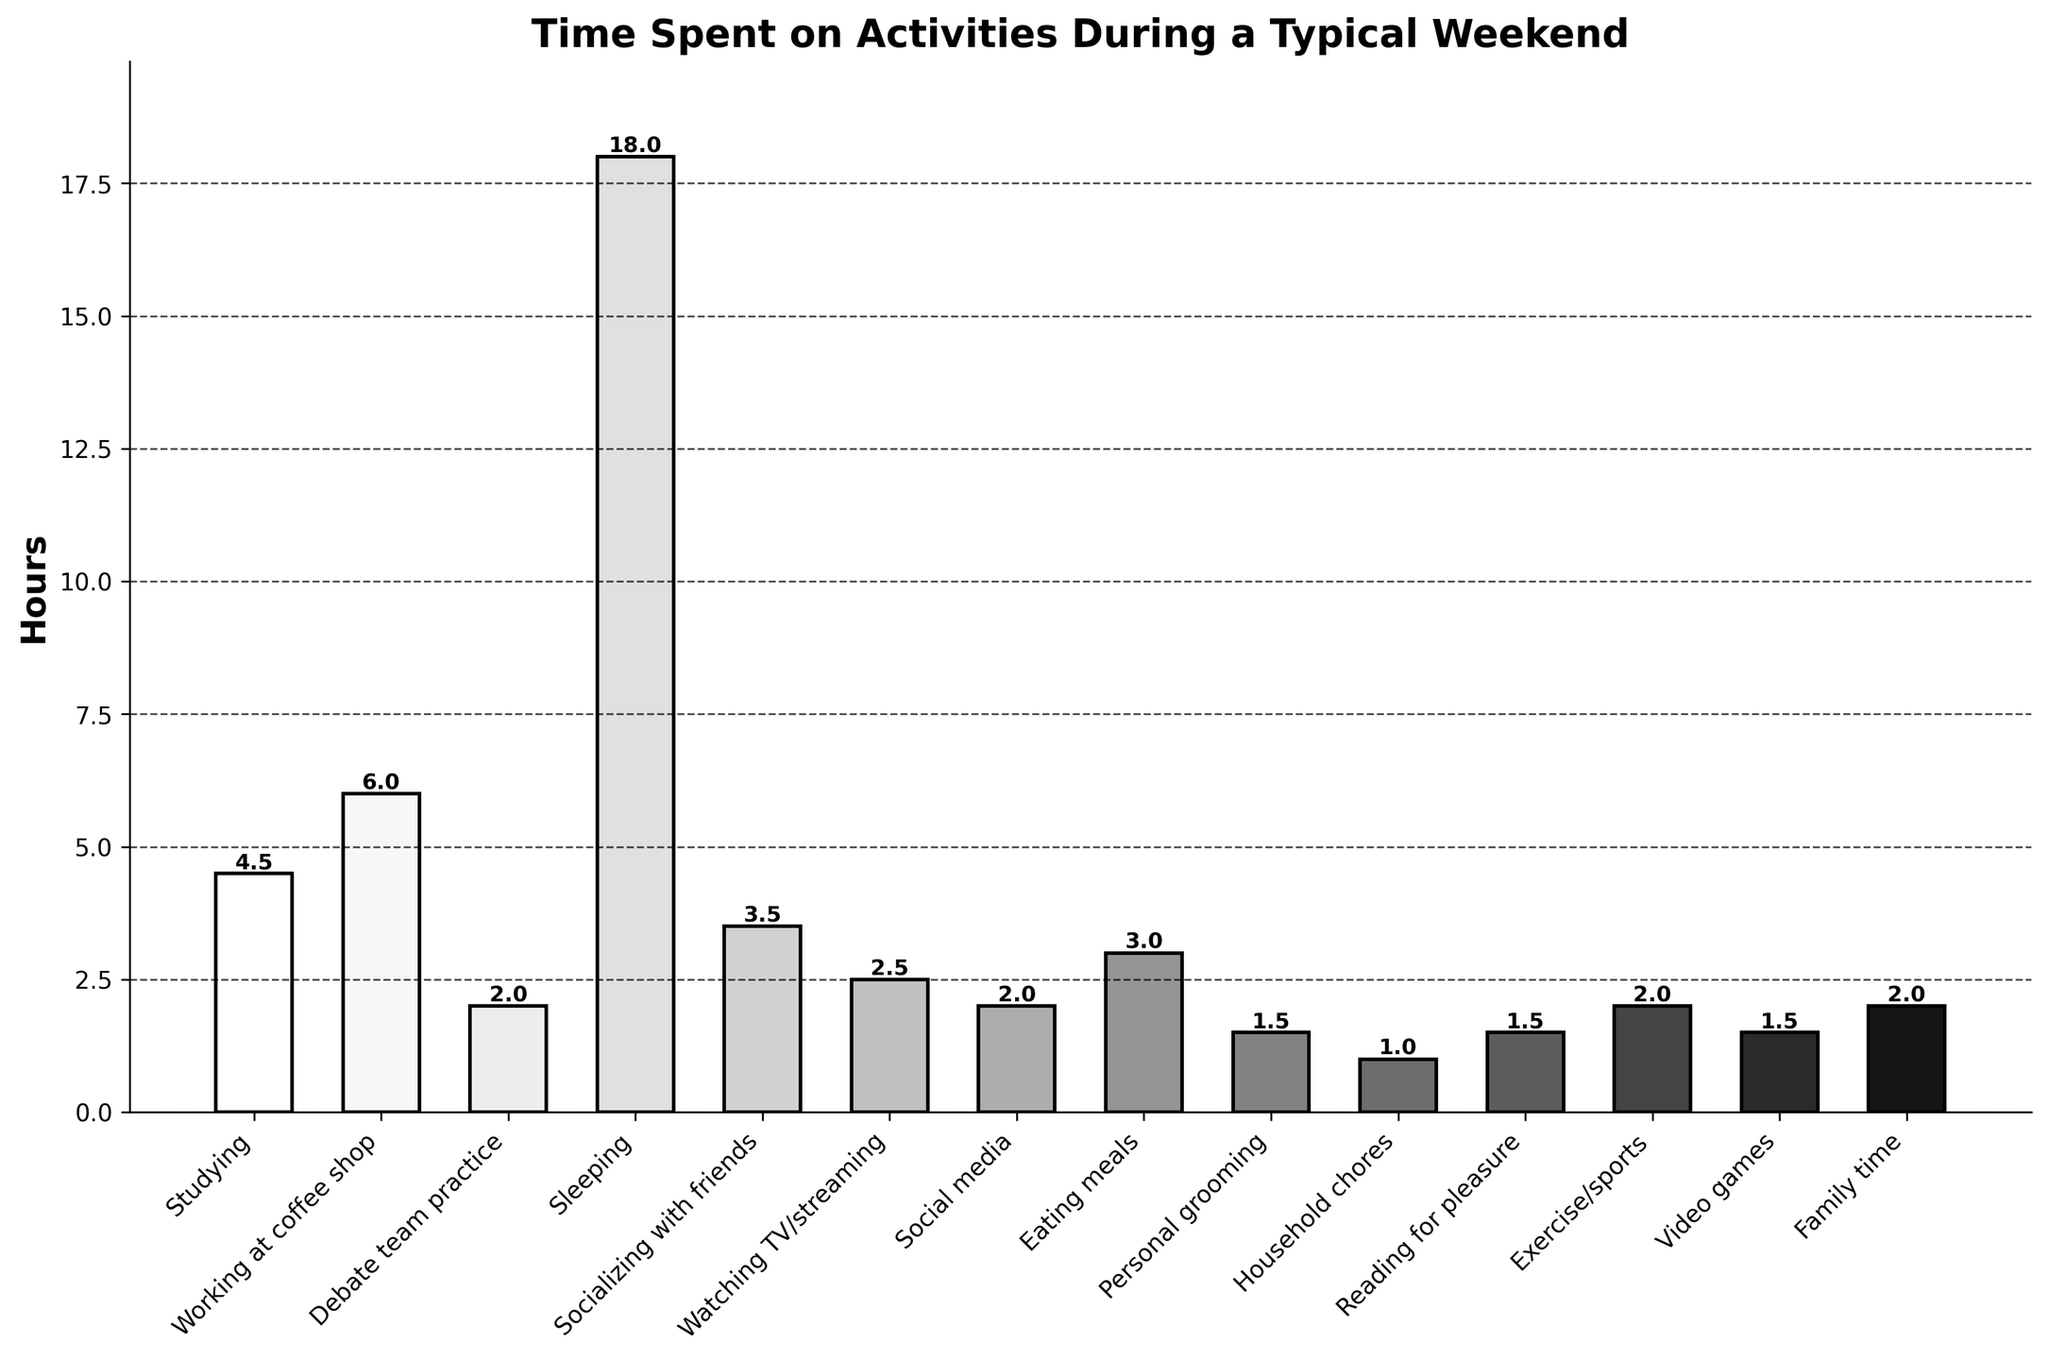What is the total number of hours spent on studying and working at the coffee shop? To find the total hours spent on studying and working at the coffee shop, add the hours spent on each activity. Studying takes 4.5 hours, and working at the coffee shop takes 6 hours. So, 4.5 + 6 = 10.5.
Answer: 10.5 Which activity has the highest number of hours spent? To determine the activity with the highest number of hours, look for the tallest bar on the bar chart. The sleeping bar is the tallest, representing 18 hours.
Answer: Sleeping How many more hours are spent sleeping compared to the time spent on socializing with friends? First, identify the hours spent sleeping (18) and the hours spent socializing with friends (3.5). Then, subtract the smaller value from the larger one: 18 - 3.5 = 14.5.
Answer: 14.5 What is the average number of hours spent on eating meals, personal grooming, and household chores? Sum the hours for eating meals (3), personal grooming (1.5), and household chores (1). The total is 3 + 1.5 + 1 = 5.5 hours. Then, divide by the number of activities: 5.5 / 3 = 1.83 (rounded to two decimal places).
Answer: 1.83 Which activities have exactly 2 hours spent on them, and how many such activities are there? Look for bars that represent exactly 2 hours. The activities are debate team practice, social media, and family time. There are 3 such activities.
Answer: Debate team practice, social media, family time. 3 activities Is more time spent watching TV/streaming or on social media? Compare the hours for watching TV/streaming (2.5) and social media (2). The taller bar represents watching TV/streaming.
Answer: Watching TV/streaming Which activity has the shortest amount of time spent and how many hours is it? Look for the shortest bar on the chart. The shortest bar represents household chores with 1 hour.
Answer: Household chores, 1 hour What is the combined time spent on reading for pleasure and playing video games? Add the hours spent on each activity: reading for pleasure (1.5) and video games (1.5). So, 1.5 + 1.5 = 3 hours.
Answer: 3 By how many hours does the time spent socializing with friends exceed the time spent on household chores? Identify the hours for socializing with friends (3.5) and household chores (1). Subtract the hours for household chores from the hours for socializing with friends: 3.5 - 1 = 2.5.
Answer: 2.5 Calculate the difference in hours between the activity with the most time spent and the activity with the least time spent. Find the difference between the hours for sleeping (18, the most time) and household chores (1, the least time): 18 - 1 = 17 hours.
Answer: 17 